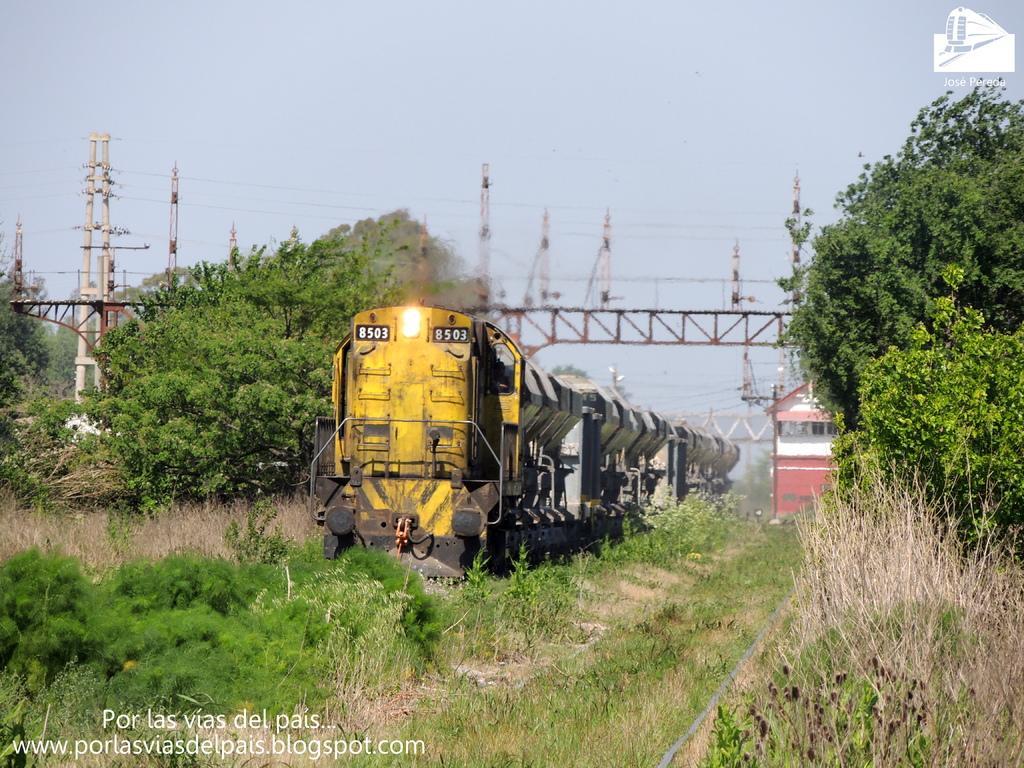Could you give a brief overview of what you see in this image? In this image I can see the train and the train is in yellow color and I can also see a light. Background I can see trees in green color, few towers and the sky is in white color. 